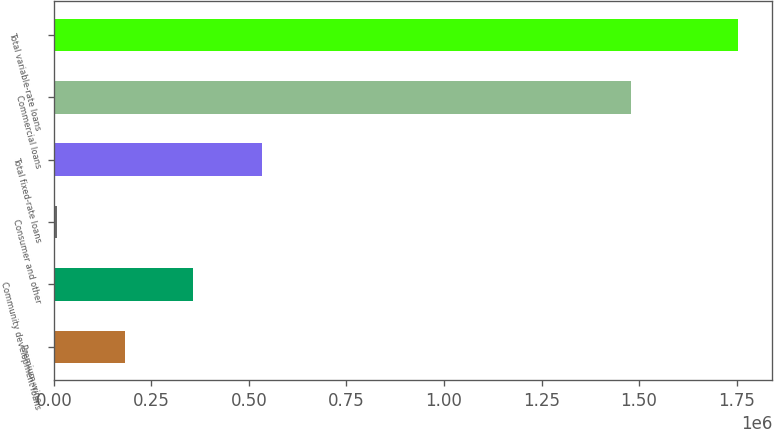<chart> <loc_0><loc_0><loc_500><loc_500><bar_chart><fcel>Premium wine<fcel>Community development loans<fcel>Consumer and other<fcel>Total fixed-rate loans<fcel>Commercial loans<fcel>Total variable-rate loans<nl><fcel>183100<fcel>357629<fcel>8572<fcel>532157<fcel>1.479e+06<fcel>1.75386e+06<nl></chart> 